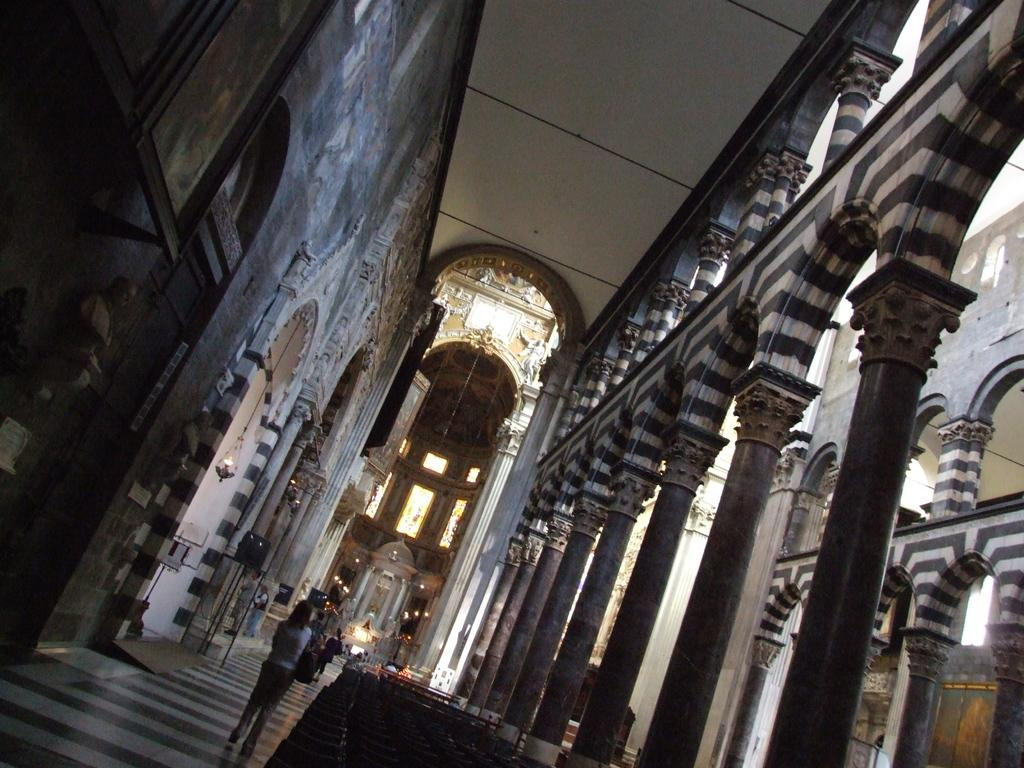What are the people in the image doing? The people in the image are walking in the corridor of a building. What decorative elements can be seen on the walls? There are statues and lamps on the walls. What architectural feature is present in the image? There are pillars in the image. What is the reaction of the truck to the people walking in the image? There is no truck present in the image, so it cannot have a reaction to the people walking. 